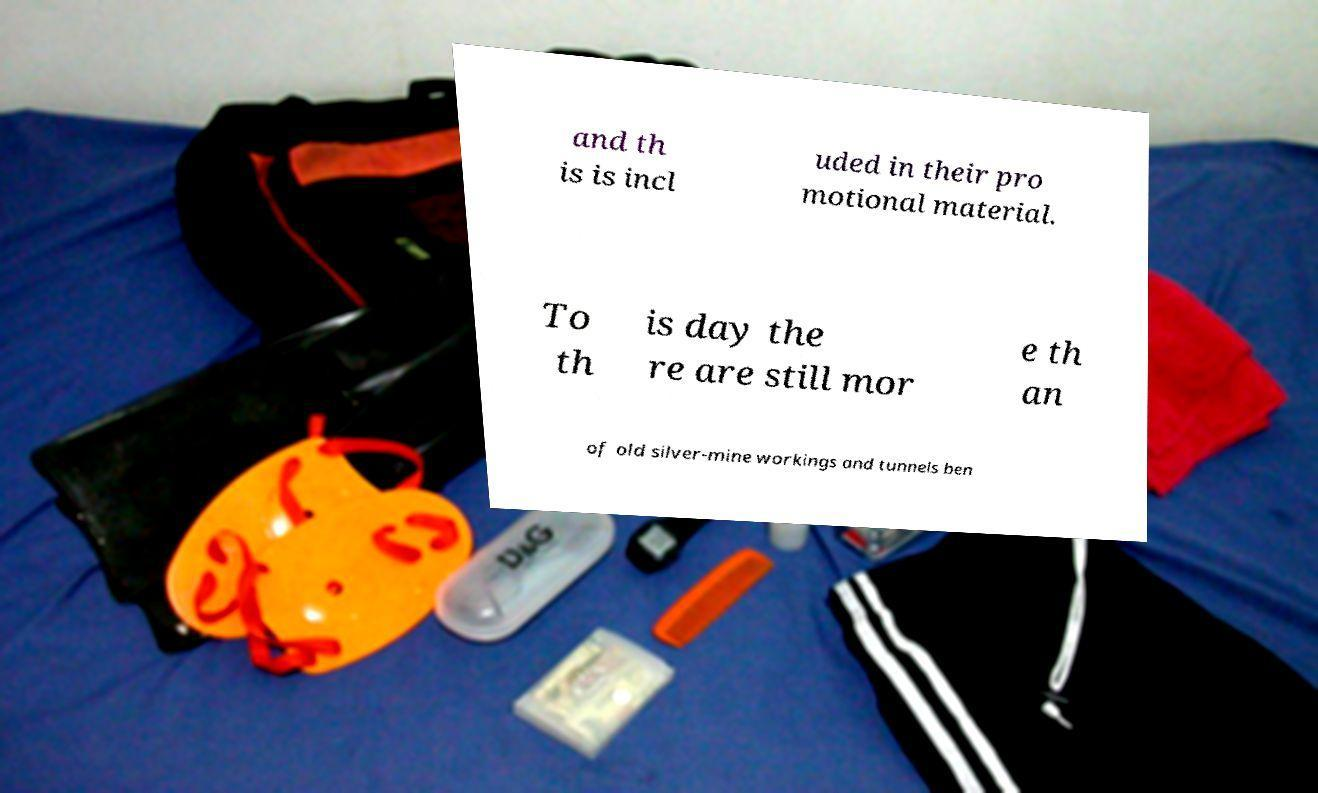I need the written content from this picture converted into text. Can you do that? and th is is incl uded in their pro motional material. To th is day the re are still mor e th an of old silver-mine workings and tunnels ben 